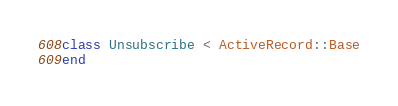Convert code to text. <code><loc_0><loc_0><loc_500><loc_500><_Ruby_>class Unsubscribe < ActiveRecord::Base
end
</code> 